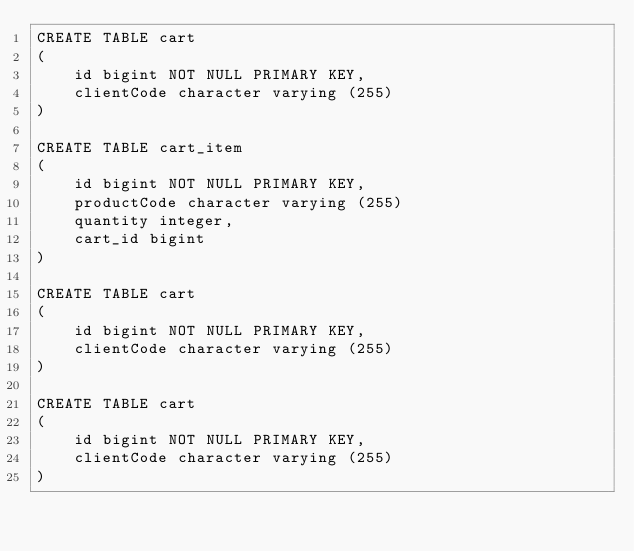Convert code to text. <code><loc_0><loc_0><loc_500><loc_500><_SQL_>CREATE TABLE cart
(
    id bigint NOT NULL PRIMARY KEY,
    clientCode character varying (255)
)

CREATE TABLE cart_item
(
    id bigint NOT NULL PRIMARY KEY,
    productCode character varying (255)
    quantity integer,
    cart_id bigint
)

CREATE TABLE cart
(
    id bigint NOT NULL PRIMARY KEY,
    clientCode character varying (255)
)

CREATE TABLE cart
(
    id bigint NOT NULL PRIMARY KEY,
    clientCode character varying (255)
)
</code> 